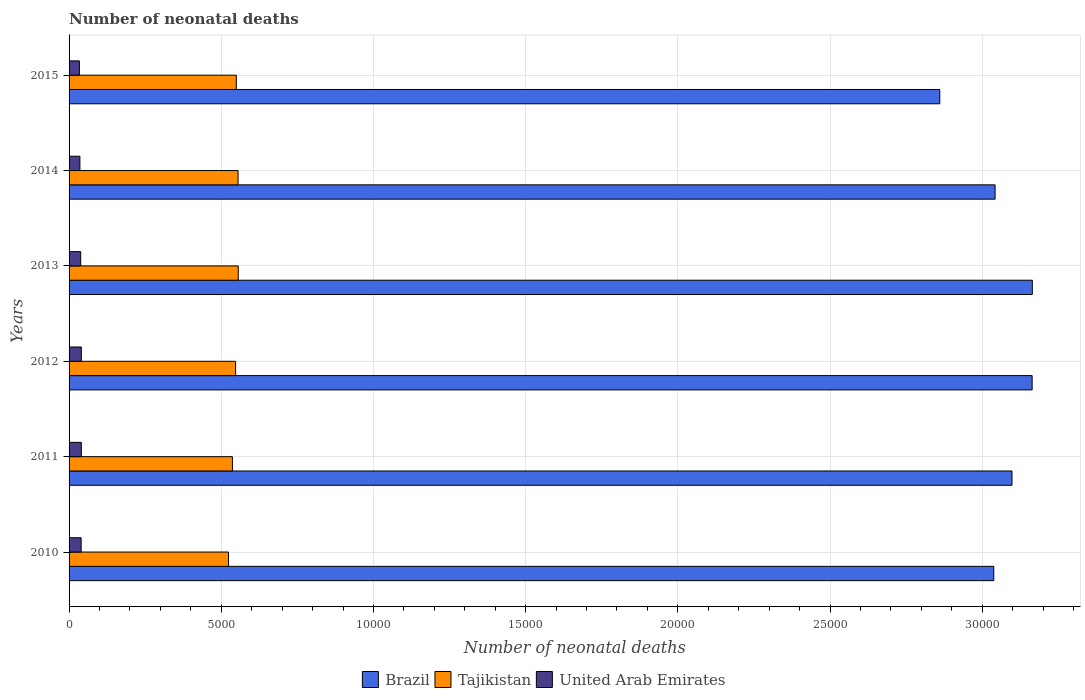How many different coloured bars are there?
Keep it short and to the point. 3. How many groups of bars are there?
Make the answer very short. 6. Are the number of bars per tick equal to the number of legend labels?
Your response must be concise. Yes. Are the number of bars on each tick of the Y-axis equal?
Your answer should be very brief. Yes. How many bars are there on the 4th tick from the top?
Your answer should be compact. 3. In how many cases, is the number of bars for a given year not equal to the number of legend labels?
Make the answer very short. 0. What is the number of neonatal deaths in in Tajikistan in 2013?
Provide a short and direct response. 5558. Across all years, what is the maximum number of neonatal deaths in in United Arab Emirates?
Provide a short and direct response. 403. Across all years, what is the minimum number of neonatal deaths in in Tajikistan?
Your answer should be very brief. 5237. In which year was the number of neonatal deaths in in Brazil maximum?
Your answer should be compact. 2013. In which year was the number of neonatal deaths in in Brazil minimum?
Ensure brevity in your answer.  2015. What is the total number of neonatal deaths in in United Arab Emirates in the graph?
Your response must be concise. 2279. What is the difference between the number of neonatal deaths in in Brazil in 2010 and that in 2012?
Provide a succinct answer. -1261. What is the difference between the number of neonatal deaths in in Brazil in 2015 and the number of neonatal deaths in in Tajikistan in 2012?
Provide a short and direct response. 2.31e+04. What is the average number of neonatal deaths in in Tajikistan per year?
Provide a succinct answer. 5446.33. In the year 2015, what is the difference between the number of neonatal deaths in in Brazil and number of neonatal deaths in in United Arab Emirates?
Your answer should be compact. 2.83e+04. In how many years, is the number of neonatal deaths in in Tajikistan greater than 18000 ?
Give a very brief answer. 0. What is the ratio of the number of neonatal deaths in in Brazil in 2010 to that in 2011?
Give a very brief answer. 0.98. What is the difference between the highest and the lowest number of neonatal deaths in in Brazil?
Offer a terse response. 3041. What does the 3rd bar from the top in 2010 represents?
Make the answer very short. Brazil. What does the 2nd bar from the bottom in 2011 represents?
Offer a very short reply. Tajikistan. How many bars are there?
Ensure brevity in your answer.  18. How many years are there in the graph?
Your response must be concise. 6. What is the difference between two consecutive major ticks on the X-axis?
Your answer should be compact. 5000. Are the values on the major ticks of X-axis written in scientific E-notation?
Offer a terse response. No. Does the graph contain any zero values?
Your response must be concise. No. Where does the legend appear in the graph?
Ensure brevity in your answer.  Bottom center. What is the title of the graph?
Ensure brevity in your answer.  Number of neonatal deaths. What is the label or title of the X-axis?
Keep it short and to the point. Number of neonatal deaths. What is the Number of neonatal deaths of Brazil in 2010?
Provide a succinct answer. 3.04e+04. What is the Number of neonatal deaths in Tajikistan in 2010?
Your response must be concise. 5237. What is the Number of neonatal deaths in United Arab Emirates in 2010?
Provide a succinct answer. 396. What is the Number of neonatal deaths of Brazil in 2011?
Give a very brief answer. 3.10e+04. What is the Number of neonatal deaths in Tajikistan in 2011?
Keep it short and to the point. 5366. What is the Number of neonatal deaths in United Arab Emirates in 2011?
Provide a short and direct response. 403. What is the Number of neonatal deaths in Brazil in 2012?
Provide a short and direct response. 3.16e+04. What is the Number of neonatal deaths of Tajikistan in 2012?
Provide a short and direct response. 5471. What is the Number of neonatal deaths in United Arab Emirates in 2012?
Offer a terse response. 403. What is the Number of neonatal deaths in Brazil in 2013?
Provide a short and direct response. 3.16e+04. What is the Number of neonatal deaths in Tajikistan in 2013?
Give a very brief answer. 5558. What is the Number of neonatal deaths in United Arab Emirates in 2013?
Your answer should be very brief. 382. What is the Number of neonatal deaths in Brazil in 2014?
Your response must be concise. 3.04e+04. What is the Number of neonatal deaths of Tajikistan in 2014?
Give a very brief answer. 5552. What is the Number of neonatal deaths of United Arab Emirates in 2014?
Give a very brief answer. 356. What is the Number of neonatal deaths of Brazil in 2015?
Your response must be concise. 2.86e+04. What is the Number of neonatal deaths of Tajikistan in 2015?
Your answer should be compact. 5494. What is the Number of neonatal deaths in United Arab Emirates in 2015?
Your response must be concise. 339. Across all years, what is the maximum Number of neonatal deaths in Brazil?
Offer a terse response. 3.16e+04. Across all years, what is the maximum Number of neonatal deaths of Tajikistan?
Ensure brevity in your answer.  5558. Across all years, what is the maximum Number of neonatal deaths in United Arab Emirates?
Keep it short and to the point. 403. Across all years, what is the minimum Number of neonatal deaths in Brazil?
Provide a succinct answer. 2.86e+04. Across all years, what is the minimum Number of neonatal deaths of Tajikistan?
Offer a terse response. 5237. Across all years, what is the minimum Number of neonatal deaths in United Arab Emirates?
Offer a very short reply. 339. What is the total Number of neonatal deaths in Brazil in the graph?
Keep it short and to the point. 1.84e+05. What is the total Number of neonatal deaths in Tajikistan in the graph?
Make the answer very short. 3.27e+04. What is the total Number of neonatal deaths of United Arab Emirates in the graph?
Keep it short and to the point. 2279. What is the difference between the Number of neonatal deaths of Brazil in 2010 and that in 2011?
Your answer should be very brief. -599. What is the difference between the Number of neonatal deaths in Tajikistan in 2010 and that in 2011?
Provide a succinct answer. -129. What is the difference between the Number of neonatal deaths of United Arab Emirates in 2010 and that in 2011?
Provide a succinct answer. -7. What is the difference between the Number of neonatal deaths of Brazil in 2010 and that in 2012?
Give a very brief answer. -1261. What is the difference between the Number of neonatal deaths of Tajikistan in 2010 and that in 2012?
Give a very brief answer. -234. What is the difference between the Number of neonatal deaths in Brazil in 2010 and that in 2013?
Keep it short and to the point. -1267. What is the difference between the Number of neonatal deaths of Tajikistan in 2010 and that in 2013?
Your answer should be compact. -321. What is the difference between the Number of neonatal deaths in Brazil in 2010 and that in 2014?
Provide a succinct answer. -43. What is the difference between the Number of neonatal deaths in Tajikistan in 2010 and that in 2014?
Provide a short and direct response. -315. What is the difference between the Number of neonatal deaths of United Arab Emirates in 2010 and that in 2014?
Offer a terse response. 40. What is the difference between the Number of neonatal deaths of Brazil in 2010 and that in 2015?
Provide a short and direct response. 1774. What is the difference between the Number of neonatal deaths in Tajikistan in 2010 and that in 2015?
Offer a very short reply. -257. What is the difference between the Number of neonatal deaths of United Arab Emirates in 2010 and that in 2015?
Offer a terse response. 57. What is the difference between the Number of neonatal deaths of Brazil in 2011 and that in 2012?
Offer a terse response. -662. What is the difference between the Number of neonatal deaths of Tajikistan in 2011 and that in 2012?
Give a very brief answer. -105. What is the difference between the Number of neonatal deaths of Brazil in 2011 and that in 2013?
Ensure brevity in your answer.  -668. What is the difference between the Number of neonatal deaths of Tajikistan in 2011 and that in 2013?
Provide a succinct answer. -192. What is the difference between the Number of neonatal deaths of United Arab Emirates in 2011 and that in 2013?
Your answer should be compact. 21. What is the difference between the Number of neonatal deaths of Brazil in 2011 and that in 2014?
Offer a terse response. 556. What is the difference between the Number of neonatal deaths of Tajikistan in 2011 and that in 2014?
Your answer should be very brief. -186. What is the difference between the Number of neonatal deaths of United Arab Emirates in 2011 and that in 2014?
Make the answer very short. 47. What is the difference between the Number of neonatal deaths of Brazil in 2011 and that in 2015?
Your answer should be compact. 2373. What is the difference between the Number of neonatal deaths in Tajikistan in 2011 and that in 2015?
Ensure brevity in your answer.  -128. What is the difference between the Number of neonatal deaths of United Arab Emirates in 2011 and that in 2015?
Your answer should be very brief. 64. What is the difference between the Number of neonatal deaths in Brazil in 2012 and that in 2013?
Provide a succinct answer. -6. What is the difference between the Number of neonatal deaths in Tajikistan in 2012 and that in 2013?
Offer a very short reply. -87. What is the difference between the Number of neonatal deaths of United Arab Emirates in 2012 and that in 2013?
Offer a terse response. 21. What is the difference between the Number of neonatal deaths of Brazil in 2012 and that in 2014?
Your answer should be very brief. 1218. What is the difference between the Number of neonatal deaths of Tajikistan in 2012 and that in 2014?
Your response must be concise. -81. What is the difference between the Number of neonatal deaths in Brazil in 2012 and that in 2015?
Offer a terse response. 3035. What is the difference between the Number of neonatal deaths in Tajikistan in 2012 and that in 2015?
Provide a short and direct response. -23. What is the difference between the Number of neonatal deaths of Brazil in 2013 and that in 2014?
Make the answer very short. 1224. What is the difference between the Number of neonatal deaths in United Arab Emirates in 2013 and that in 2014?
Your answer should be very brief. 26. What is the difference between the Number of neonatal deaths of Brazil in 2013 and that in 2015?
Offer a terse response. 3041. What is the difference between the Number of neonatal deaths of Tajikistan in 2013 and that in 2015?
Provide a short and direct response. 64. What is the difference between the Number of neonatal deaths in United Arab Emirates in 2013 and that in 2015?
Provide a short and direct response. 43. What is the difference between the Number of neonatal deaths of Brazil in 2014 and that in 2015?
Your answer should be compact. 1817. What is the difference between the Number of neonatal deaths in Tajikistan in 2014 and that in 2015?
Offer a terse response. 58. What is the difference between the Number of neonatal deaths in Brazil in 2010 and the Number of neonatal deaths in Tajikistan in 2011?
Your answer should be very brief. 2.50e+04. What is the difference between the Number of neonatal deaths of Brazil in 2010 and the Number of neonatal deaths of United Arab Emirates in 2011?
Your answer should be compact. 3.00e+04. What is the difference between the Number of neonatal deaths in Tajikistan in 2010 and the Number of neonatal deaths in United Arab Emirates in 2011?
Make the answer very short. 4834. What is the difference between the Number of neonatal deaths in Brazil in 2010 and the Number of neonatal deaths in Tajikistan in 2012?
Provide a succinct answer. 2.49e+04. What is the difference between the Number of neonatal deaths in Brazil in 2010 and the Number of neonatal deaths in United Arab Emirates in 2012?
Provide a short and direct response. 3.00e+04. What is the difference between the Number of neonatal deaths in Tajikistan in 2010 and the Number of neonatal deaths in United Arab Emirates in 2012?
Keep it short and to the point. 4834. What is the difference between the Number of neonatal deaths of Brazil in 2010 and the Number of neonatal deaths of Tajikistan in 2013?
Offer a very short reply. 2.48e+04. What is the difference between the Number of neonatal deaths in Brazil in 2010 and the Number of neonatal deaths in United Arab Emirates in 2013?
Your answer should be compact. 3.00e+04. What is the difference between the Number of neonatal deaths in Tajikistan in 2010 and the Number of neonatal deaths in United Arab Emirates in 2013?
Your answer should be very brief. 4855. What is the difference between the Number of neonatal deaths in Brazil in 2010 and the Number of neonatal deaths in Tajikistan in 2014?
Keep it short and to the point. 2.48e+04. What is the difference between the Number of neonatal deaths of Brazil in 2010 and the Number of neonatal deaths of United Arab Emirates in 2014?
Your answer should be compact. 3.00e+04. What is the difference between the Number of neonatal deaths in Tajikistan in 2010 and the Number of neonatal deaths in United Arab Emirates in 2014?
Offer a terse response. 4881. What is the difference between the Number of neonatal deaths of Brazil in 2010 and the Number of neonatal deaths of Tajikistan in 2015?
Ensure brevity in your answer.  2.49e+04. What is the difference between the Number of neonatal deaths of Brazil in 2010 and the Number of neonatal deaths of United Arab Emirates in 2015?
Your response must be concise. 3.00e+04. What is the difference between the Number of neonatal deaths in Tajikistan in 2010 and the Number of neonatal deaths in United Arab Emirates in 2015?
Provide a short and direct response. 4898. What is the difference between the Number of neonatal deaths in Brazil in 2011 and the Number of neonatal deaths in Tajikistan in 2012?
Your response must be concise. 2.55e+04. What is the difference between the Number of neonatal deaths of Brazil in 2011 and the Number of neonatal deaths of United Arab Emirates in 2012?
Offer a terse response. 3.06e+04. What is the difference between the Number of neonatal deaths of Tajikistan in 2011 and the Number of neonatal deaths of United Arab Emirates in 2012?
Make the answer very short. 4963. What is the difference between the Number of neonatal deaths of Brazil in 2011 and the Number of neonatal deaths of Tajikistan in 2013?
Offer a very short reply. 2.54e+04. What is the difference between the Number of neonatal deaths of Brazil in 2011 and the Number of neonatal deaths of United Arab Emirates in 2013?
Provide a succinct answer. 3.06e+04. What is the difference between the Number of neonatal deaths of Tajikistan in 2011 and the Number of neonatal deaths of United Arab Emirates in 2013?
Your answer should be compact. 4984. What is the difference between the Number of neonatal deaths in Brazil in 2011 and the Number of neonatal deaths in Tajikistan in 2014?
Your answer should be compact. 2.54e+04. What is the difference between the Number of neonatal deaths in Brazil in 2011 and the Number of neonatal deaths in United Arab Emirates in 2014?
Offer a very short reply. 3.06e+04. What is the difference between the Number of neonatal deaths of Tajikistan in 2011 and the Number of neonatal deaths of United Arab Emirates in 2014?
Give a very brief answer. 5010. What is the difference between the Number of neonatal deaths of Brazil in 2011 and the Number of neonatal deaths of Tajikistan in 2015?
Your answer should be compact. 2.55e+04. What is the difference between the Number of neonatal deaths of Brazil in 2011 and the Number of neonatal deaths of United Arab Emirates in 2015?
Your response must be concise. 3.06e+04. What is the difference between the Number of neonatal deaths in Tajikistan in 2011 and the Number of neonatal deaths in United Arab Emirates in 2015?
Give a very brief answer. 5027. What is the difference between the Number of neonatal deaths of Brazil in 2012 and the Number of neonatal deaths of Tajikistan in 2013?
Provide a succinct answer. 2.61e+04. What is the difference between the Number of neonatal deaths of Brazil in 2012 and the Number of neonatal deaths of United Arab Emirates in 2013?
Provide a succinct answer. 3.13e+04. What is the difference between the Number of neonatal deaths of Tajikistan in 2012 and the Number of neonatal deaths of United Arab Emirates in 2013?
Your answer should be compact. 5089. What is the difference between the Number of neonatal deaths of Brazil in 2012 and the Number of neonatal deaths of Tajikistan in 2014?
Give a very brief answer. 2.61e+04. What is the difference between the Number of neonatal deaths of Brazil in 2012 and the Number of neonatal deaths of United Arab Emirates in 2014?
Give a very brief answer. 3.13e+04. What is the difference between the Number of neonatal deaths of Tajikistan in 2012 and the Number of neonatal deaths of United Arab Emirates in 2014?
Offer a very short reply. 5115. What is the difference between the Number of neonatal deaths of Brazil in 2012 and the Number of neonatal deaths of Tajikistan in 2015?
Your answer should be very brief. 2.61e+04. What is the difference between the Number of neonatal deaths of Brazil in 2012 and the Number of neonatal deaths of United Arab Emirates in 2015?
Ensure brevity in your answer.  3.13e+04. What is the difference between the Number of neonatal deaths in Tajikistan in 2012 and the Number of neonatal deaths in United Arab Emirates in 2015?
Your response must be concise. 5132. What is the difference between the Number of neonatal deaths in Brazil in 2013 and the Number of neonatal deaths in Tajikistan in 2014?
Ensure brevity in your answer.  2.61e+04. What is the difference between the Number of neonatal deaths in Brazil in 2013 and the Number of neonatal deaths in United Arab Emirates in 2014?
Offer a terse response. 3.13e+04. What is the difference between the Number of neonatal deaths in Tajikistan in 2013 and the Number of neonatal deaths in United Arab Emirates in 2014?
Keep it short and to the point. 5202. What is the difference between the Number of neonatal deaths of Brazil in 2013 and the Number of neonatal deaths of Tajikistan in 2015?
Offer a very short reply. 2.62e+04. What is the difference between the Number of neonatal deaths in Brazil in 2013 and the Number of neonatal deaths in United Arab Emirates in 2015?
Offer a very short reply. 3.13e+04. What is the difference between the Number of neonatal deaths in Tajikistan in 2013 and the Number of neonatal deaths in United Arab Emirates in 2015?
Give a very brief answer. 5219. What is the difference between the Number of neonatal deaths in Brazil in 2014 and the Number of neonatal deaths in Tajikistan in 2015?
Offer a terse response. 2.49e+04. What is the difference between the Number of neonatal deaths of Brazil in 2014 and the Number of neonatal deaths of United Arab Emirates in 2015?
Make the answer very short. 3.01e+04. What is the difference between the Number of neonatal deaths in Tajikistan in 2014 and the Number of neonatal deaths in United Arab Emirates in 2015?
Give a very brief answer. 5213. What is the average Number of neonatal deaths in Brazil per year?
Keep it short and to the point. 3.06e+04. What is the average Number of neonatal deaths of Tajikistan per year?
Provide a succinct answer. 5446.33. What is the average Number of neonatal deaths of United Arab Emirates per year?
Provide a short and direct response. 379.83. In the year 2010, what is the difference between the Number of neonatal deaths of Brazil and Number of neonatal deaths of Tajikistan?
Offer a very short reply. 2.51e+04. In the year 2010, what is the difference between the Number of neonatal deaths of Brazil and Number of neonatal deaths of United Arab Emirates?
Your answer should be very brief. 3.00e+04. In the year 2010, what is the difference between the Number of neonatal deaths of Tajikistan and Number of neonatal deaths of United Arab Emirates?
Keep it short and to the point. 4841. In the year 2011, what is the difference between the Number of neonatal deaths of Brazil and Number of neonatal deaths of Tajikistan?
Provide a short and direct response. 2.56e+04. In the year 2011, what is the difference between the Number of neonatal deaths in Brazil and Number of neonatal deaths in United Arab Emirates?
Your response must be concise. 3.06e+04. In the year 2011, what is the difference between the Number of neonatal deaths in Tajikistan and Number of neonatal deaths in United Arab Emirates?
Your response must be concise. 4963. In the year 2012, what is the difference between the Number of neonatal deaths of Brazil and Number of neonatal deaths of Tajikistan?
Your answer should be compact. 2.62e+04. In the year 2012, what is the difference between the Number of neonatal deaths of Brazil and Number of neonatal deaths of United Arab Emirates?
Your answer should be compact. 3.12e+04. In the year 2012, what is the difference between the Number of neonatal deaths of Tajikistan and Number of neonatal deaths of United Arab Emirates?
Your answer should be very brief. 5068. In the year 2013, what is the difference between the Number of neonatal deaths of Brazil and Number of neonatal deaths of Tajikistan?
Your response must be concise. 2.61e+04. In the year 2013, what is the difference between the Number of neonatal deaths in Brazil and Number of neonatal deaths in United Arab Emirates?
Your answer should be compact. 3.13e+04. In the year 2013, what is the difference between the Number of neonatal deaths in Tajikistan and Number of neonatal deaths in United Arab Emirates?
Provide a succinct answer. 5176. In the year 2014, what is the difference between the Number of neonatal deaths of Brazil and Number of neonatal deaths of Tajikistan?
Ensure brevity in your answer.  2.49e+04. In the year 2014, what is the difference between the Number of neonatal deaths of Brazil and Number of neonatal deaths of United Arab Emirates?
Give a very brief answer. 3.01e+04. In the year 2014, what is the difference between the Number of neonatal deaths of Tajikistan and Number of neonatal deaths of United Arab Emirates?
Keep it short and to the point. 5196. In the year 2015, what is the difference between the Number of neonatal deaths in Brazil and Number of neonatal deaths in Tajikistan?
Ensure brevity in your answer.  2.31e+04. In the year 2015, what is the difference between the Number of neonatal deaths of Brazil and Number of neonatal deaths of United Arab Emirates?
Make the answer very short. 2.83e+04. In the year 2015, what is the difference between the Number of neonatal deaths in Tajikistan and Number of neonatal deaths in United Arab Emirates?
Provide a succinct answer. 5155. What is the ratio of the Number of neonatal deaths of Brazil in 2010 to that in 2011?
Your answer should be very brief. 0.98. What is the ratio of the Number of neonatal deaths in Tajikistan in 2010 to that in 2011?
Make the answer very short. 0.98. What is the ratio of the Number of neonatal deaths of United Arab Emirates in 2010 to that in 2011?
Offer a terse response. 0.98. What is the ratio of the Number of neonatal deaths in Brazil in 2010 to that in 2012?
Provide a short and direct response. 0.96. What is the ratio of the Number of neonatal deaths in Tajikistan in 2010 to that in 2012?
Offer a very short reply. 0.96. What is the ratio of the Number of neonatal deaths of United Arab Emirates in 2010 to that in 2012?
Your answer should be very brief. 0.98. What is the ratio of the Number of neonatal deaths in Tajikistan in 2010 to that in 2013?
Your answer should be very brief. 0.94. What is the ratio of the Number of neonatal deaths in United Arab Emirates in 2010 to that in 2013?
Provide a short and direct response. 1.04. What is the ratio of the Number of neonatal deaths in Brazil in 2010 to that in 2014?
Ensure brevity in your answer.  1. What is the ratio of the Number of neonatal deaths in Tajikistan in 2010 to that in 2014?
Your answer should be very brief. 0.94. What is the ratio of the Number of neonatal deaths of United Arab Emirates in 2010 to that in 2014?
Make the answer very short. 1.11. What is the ratio of the Number of neonatal deaths of Brazil in 2010 to that in 2015?
Give a very brief answer. 1.06. What is the ratio of the Number of neonatal deaths in Tajikistan in 2010 to that in 2015?
Keep it short and to the point. 0.95. What is the ratio of the Number of neonatal deaths of United Arab Emirates in 2010 to that in 2015?
Provide a short and direct response. 1.17. What is the ratio of the Number of neonatal deaths of Brazil in 2011 to that in 2012?
Your answer should be very brief. 0.98. What is the ratio of the Number of neonatal deaths in Tajikistan in 2011 to that in 2012?
Give a very brief answer. 0.98. What is the ratio of the Number of neonatal deaths in United Arab Emirates in 2011 to that in 2012?
Keep it short and to the point. 1. What is the ratio of the Number of neonatal deaths of Brazil in 2011 to that in 2013?
Give a very brief answer. 0.98. What is the ratio of the Number of neonatal deaths in Tajikistan in 2011 to that in 2013?
Provide a short and direct response. 0.97. What is the ratio of the Number of neonatal deaths of United Arab Emirates in 2011 to that in 2013?
Give a very brief answer. 1.05. What is the ratio of the Number of neonatal deaths in Brazil in 2011 to that in 2014?
Your answer should be compact. 1.02. What is the ratio of the Number of neonatal deaths in Tajikistan in 2011 to that in 2014?
Keep it short and to the point. 0.97. What is the ratio of the Number of neonatal deaths in United Arab Emirates in 2011 to that in 2014?
Ensure brevity in your answer.  1.13. What is the ratio of the Number of neonatal deaths in Brazil in 2011 to that in 2015?
Offer a terse response. 1.08. What is the ratio of the Number of neonatal deaths of Tajikistan in 2011 to that in 2015?
Your response must be concise. 0.98. What is the ratio of the Number of neonatal deaths in United Arab Emirates in 2011 to that in 2015?
Provide a short and direct response. 1.19. What is the ratio of the Number of neonatal deaths of Tajikistan in 2012 to that in 2013?
Make the answer very short. 0.98. What is the ratio of the Number of neonatal deaths of United Arab Emirates in 2012 to that in 2013?
Give a very brief answer. 1.05. What is the ratio of the Number of neonatal deaths in Brazil in 2012 to that in 2014?
Your answer should be compact. 1.04. What is the ratio of the Number of neonatal deaths of Tajikistan in 2012 to that in 2014?
Your answer should be very brief. 0.99. What is the ratio of the Number of neonatal deaths of United Arab Emirates in 2012 to that in 2014?
Your response must be concise. 1.13. What is the ratio of the Number of neonatal deaths of Brazil in 2012 to that in 2015?
Provide a succinct answer. 1.11. What is the ratio of the Number of neonatal deaths of United Arab Emirates in 2012 to that in 2015?
Make the answer very short. 1.19. What is the ratio of the Number of neonatal deaths of Brazil in 2013 to that in 2014?
Provide a succinct answer. 1.04. What is the ratio of the Number of neonatal deaths in United Arab Emirates in 2013 to that in 2014?
Provide a short and direct response. 1.07. What is the ratio of the Number of neonatal deaths of Brazil in 2013 to that in 2015?
Provide a succinct answer. 1.11. What is the ratio of the Number of neonatal deaths of Tajikistan in 2013 to that in 2015?
Your answer should be compact. 1.01. What is the ratio of the Number of neonatal deaths of United Arab Emirates in 2013 to that in 2015?
Provide a short and direct response. 1.13. What is the ratio of the Number of neonatal deaths in Brazil in 2014 to that in 2015?
Give a very brief answer. 1.06. What is the ratio of the Number of neonatal deaths of Tajikistan in 2014 to that in 2015?
Ensure brevity in your answer.  1.01. What is the ratio of the Number of neonatal deaths of United Arab Emirates in 2014 to that in 2015?
Offer a very short reply. 1.05. What is the difference between the highest and the second highest Number of neonatal deaths of Brazil?
Your response must be concise. 6. What is the difference between the highest and the lowest Number of neonatal deaths in Brazil?
Offer a terse response. 3041. What is the difference between the highest and the lowest Number of neonatal deaths of Tajikistan?
Give a very brief answer. 321. What is the difference between the highest and the lowest Number of neonatal deaths of United Arab Emirates?
Ensure brevity in your answer.  64. 